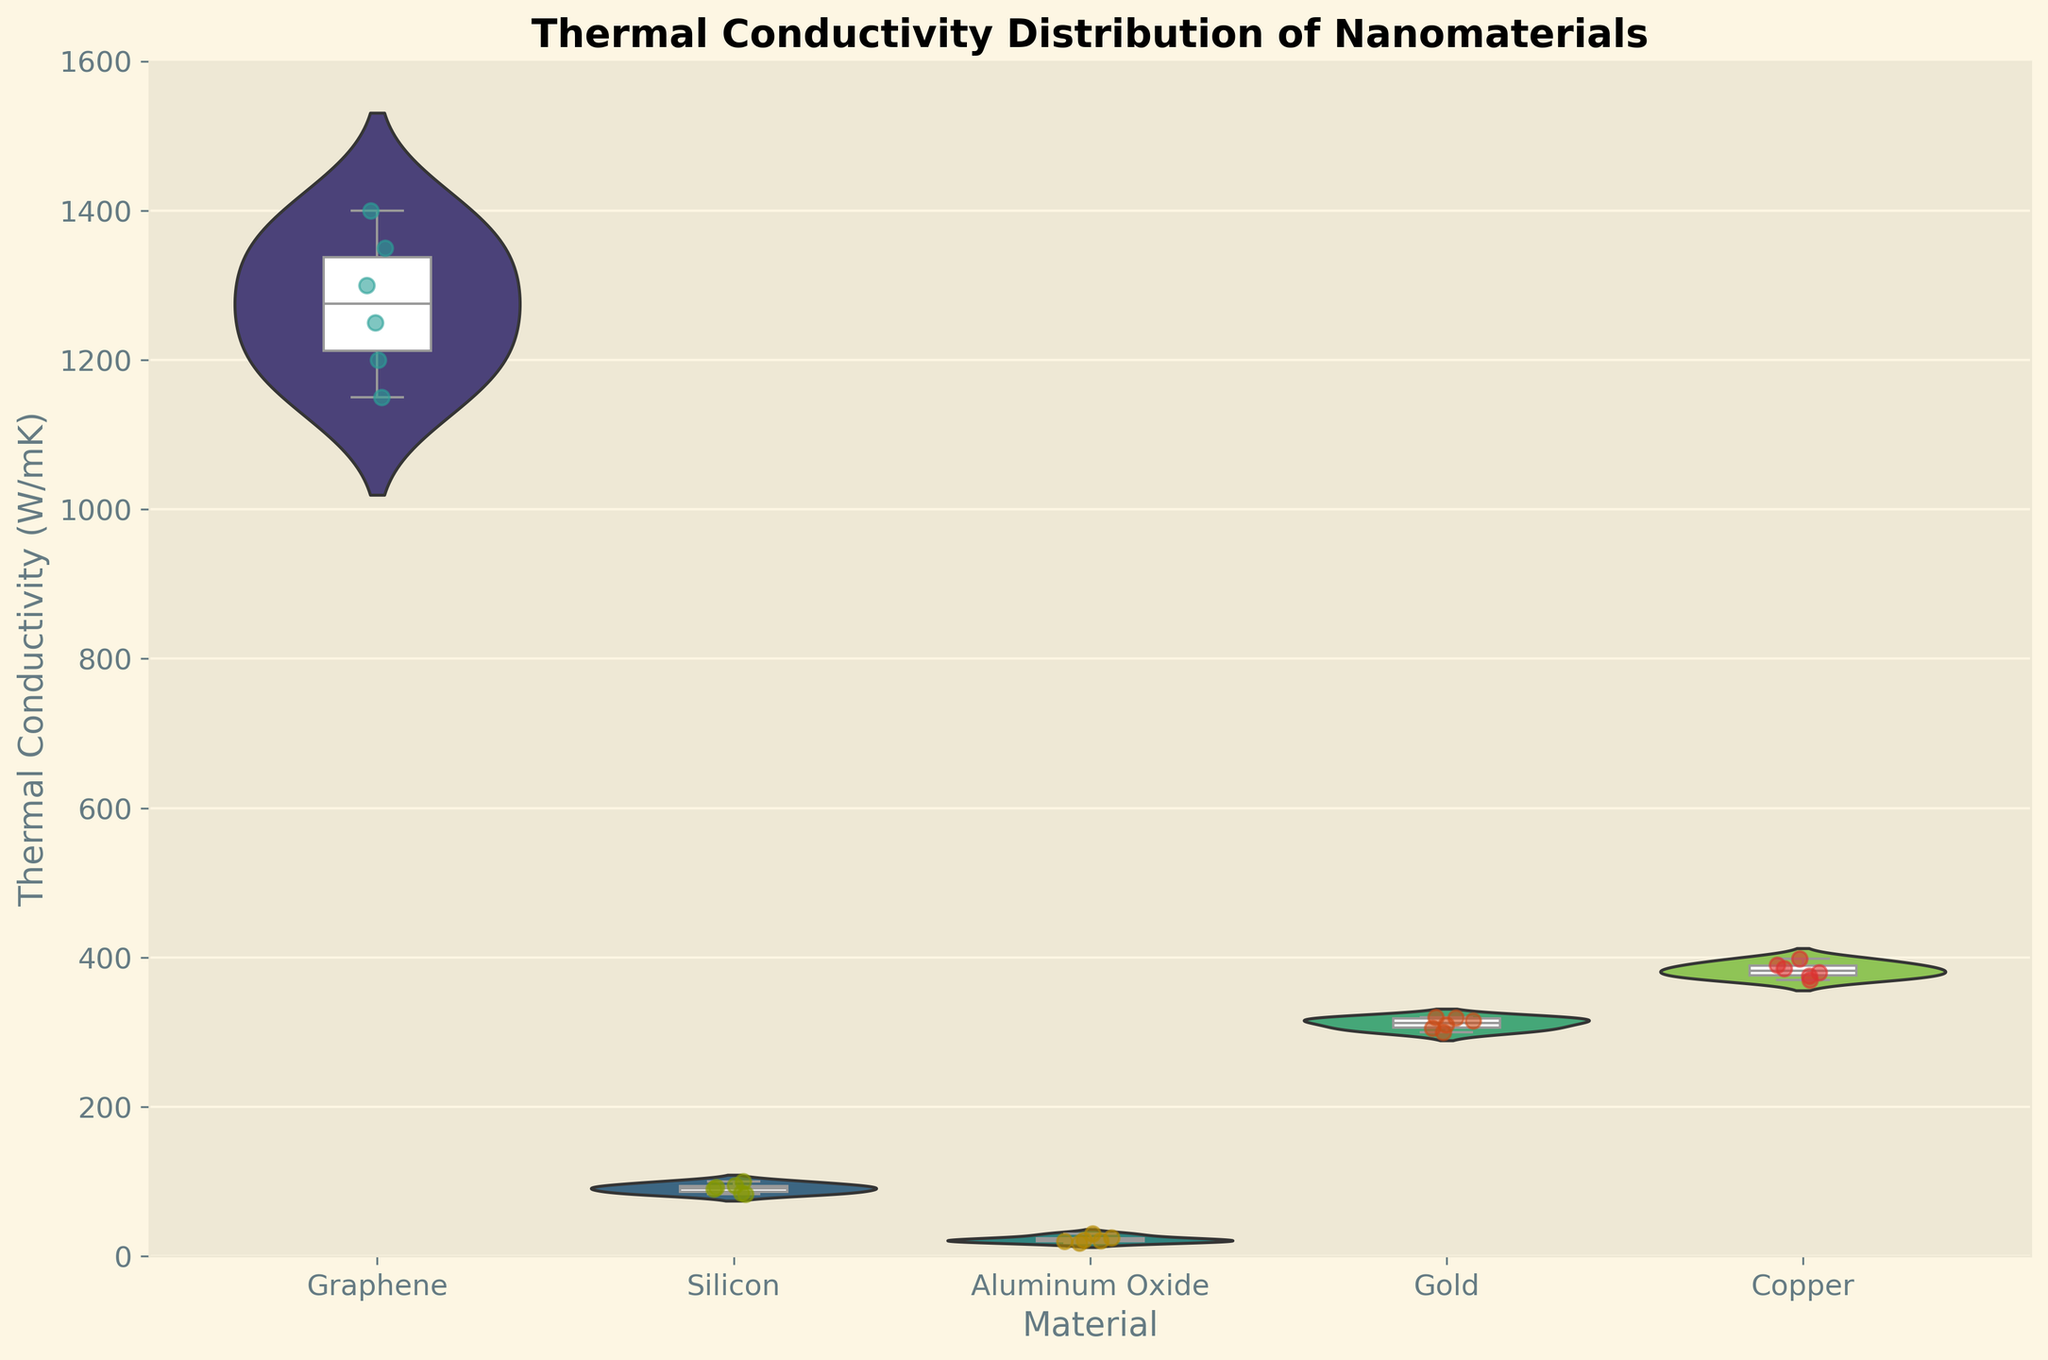What title is given to the figure? The title of the figure is usually placed at the top center. In this case, the title is clearly labeled above the graph area.
Answer: Thermal Conductivity Distribution of Nanomaterials What does the y-axis represent? The y-axis usually runs vertically and indicates the measure being plotted. Here, it has labels indicating "Thermal Conductivity (W/mK)."
Answer: Thermal Conductivity (W/mK) Which material shows the highest median thermal conductivity? By observing the central line in each box plot overlaid on the violin plots, the median value can be identified. The highest median value will be the highest central line.
Answer: Graphene Compare the interquartile range (IQR) of Copper and Silicon. Which one is wider? The IQR is the range between the first and third quartiles in a box plot (the box). By comparing the length of the boxes for Copper and Silicon, we can determine which one is wider.
Answer: Silicon What is the trend in thermal conductivity for Graphene as particle size increases? Examine the scatter plot points distribution within the Graphene violin plot for different particle sizes. An overall downward trend in thermal conductivity values as the particle size on the x-axis increases shows the trend.
Answer: It decreases Which material has the smallest variation in thermal conductivity values? The width of the violin plots indicates the variation or spread of the data. Narrower plots indicate smaller variation. By observing the widths, we can determine the material with the smallest variation.
Answer: Aluminum Oxide What is the main color palette used in the figure? By looking at the overall color scheme of the violin plots, we can identify the predominant color used, which is from the 'viridis' color palette.
Answer: Viridis Compare the maximum thermal conductivity values of Gold and Graphene. Which one is higher? The maximum value can be identified as the highest point in the scatter plot. By comparing the heights, we can determine which is higher.
Answer: Graphene What is the approximate range of thermal conductivity for materials with a particle size of 10 nm? Observing the scatter plots and the spread of data points for each material when the particle size is 10 nm, the range can be estimated from the minimum to the maximum y-axis value seen there.
Answer: 30 to 1400 W/mK How does the thermal conductivity distribution of Silicon change with particle size? By examining the Silicon violin plots and noting changes in their width and median line position with increasing particle size, the trend in distribution can be assessed.
Answer: It slightly decreases 